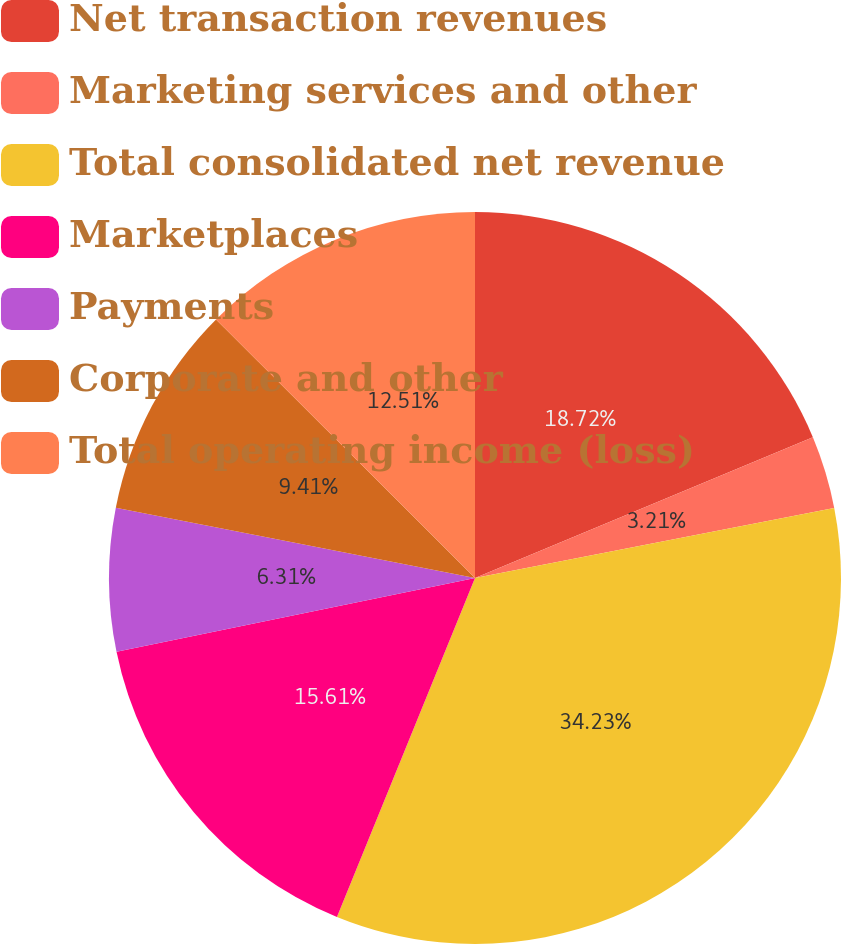<chart> <loc_0><loc_0><loc_500><loc_500><pie_chart><fcel>Net transaction revenues<fcel>Marketing services and other<fcel>Total consolidated net revenue<fcel>Marketplaces<fcel>Payments<fcel>Corporate and other<fcel>Total operating income (loss)<nl><fcel>18.72%<fcel>3.21%<fcel>34.22%<fcel>15.61%<fcel>6.31%<fcel>9.41%<fcel>12.51%<nl></chart> 